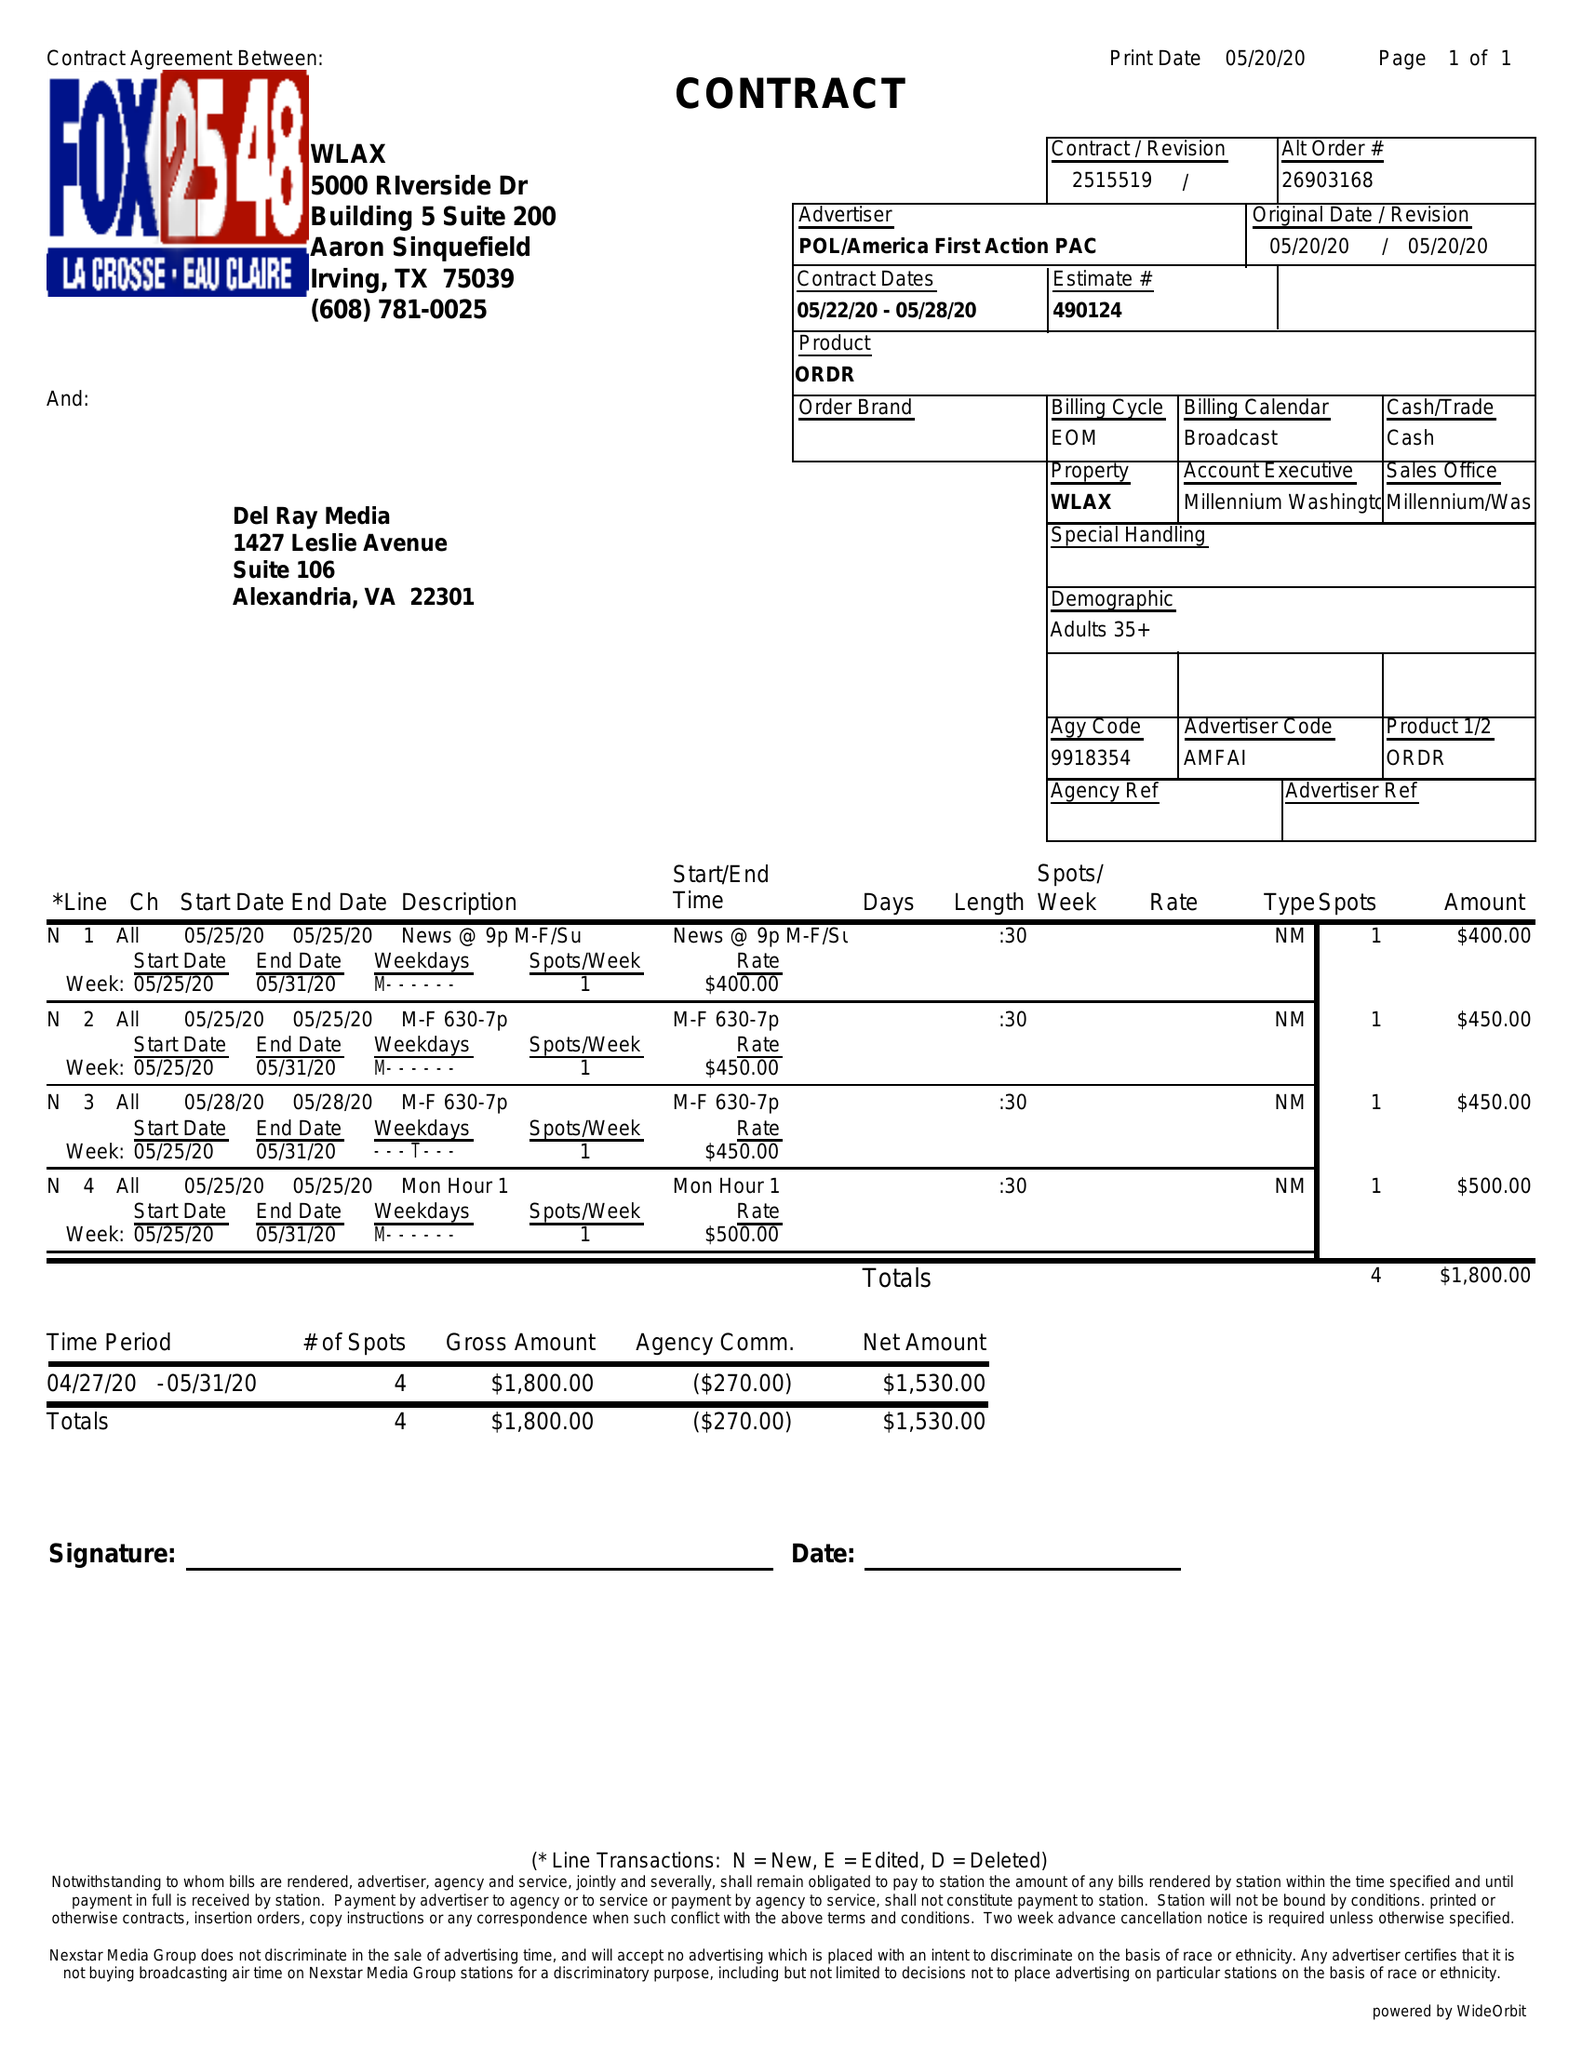What is the value for the flight_to?
Answer the question using a single word or phrase. 05/28/20 